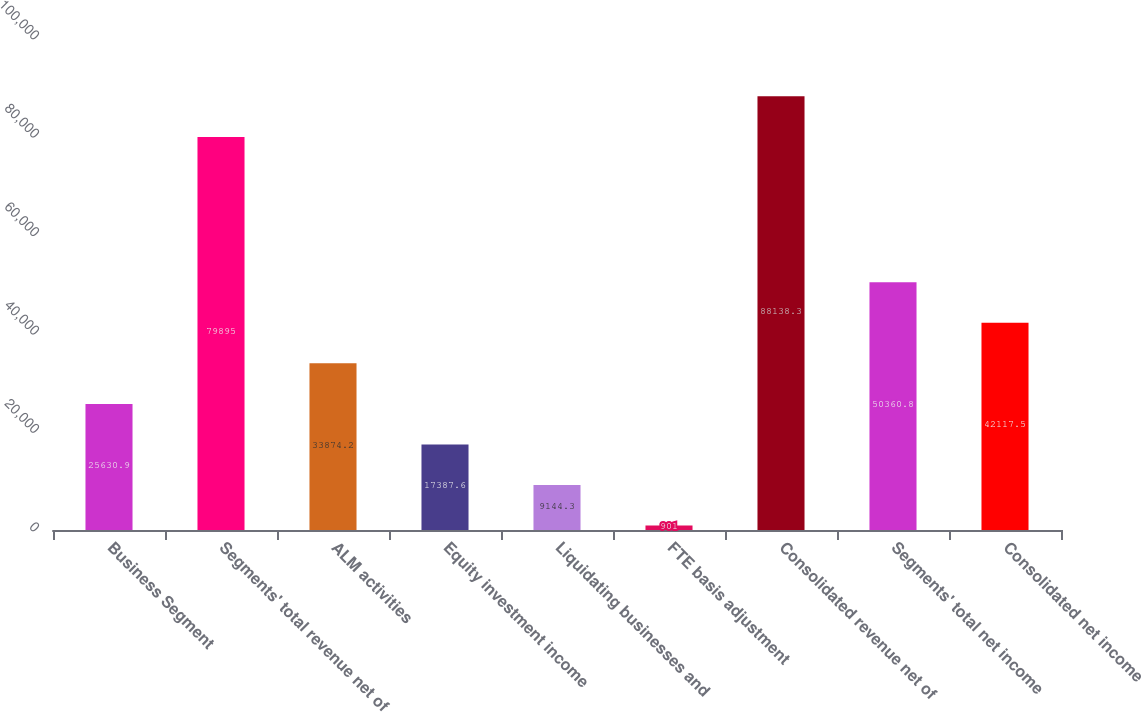Convert chart to OTSL. <chart><loc_0><loc_0><loc_500><loc_500><bar_chart><fcel>Business Segment<fcel>Segments' total revenue net of<fcel>ALM activities<fcel>Equity investment income<fcel>Liquidating businesses and<fcel>FTE basis adjustment<fcel>Consolidated revenue net of<fcel>Segments' total net income<fcel>Consolidated net income<nl><fcel>25630.9<fcel>79895<fcel>33874.2<fcel>17387.6<fcel>9144.3<fcel>901<fcel>88138.3<fcel>50360.8<fcel>42117.5<nl></chart> 